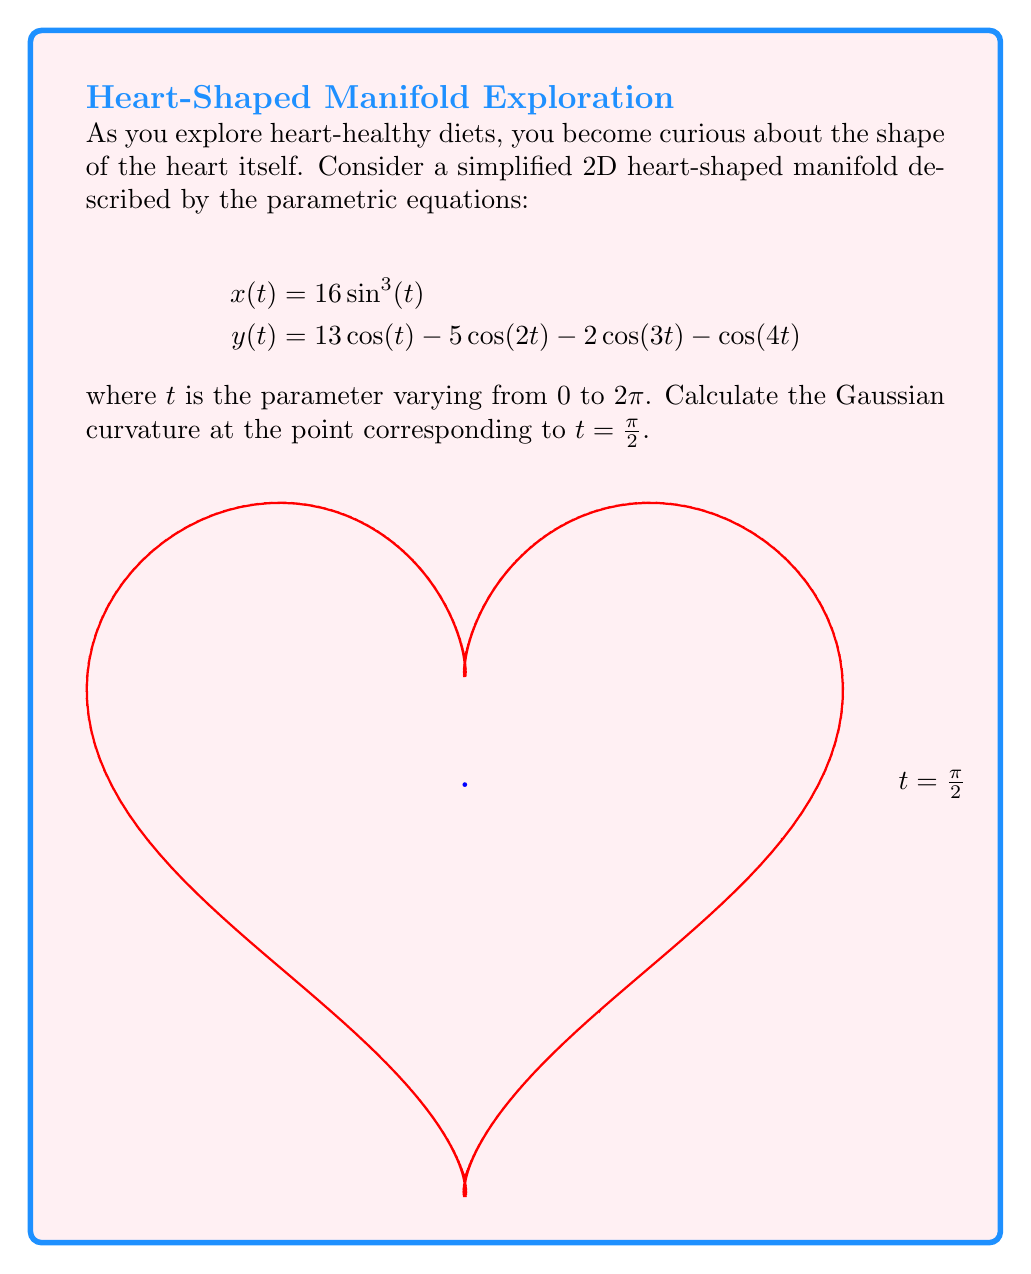Teach me how to tackle this problem. To calculate the Gaussian curvature, we need to follow these steps:

1) First, we need to calculate the first and second derivatives of x and y with respect to t:

   $$x'(t) = 48\sin^2(t)\cos(t)$$
   $$y'(t) = -13\sin(t) + 10\sin(2t) + 6\sin(3t) + 4\sin(4t)$$
   
   $$x''(t) = 96\sin(t)\cos^2(t) - 48\sin^3(t)$$
   $$y''(t) = -13\cos(t) + 20\cos(2t) + 18\cos(3t) + 16\cos(4t)$$

2) At $t = \frac{\pi}{2}$, we have:

   $$x'(\frac{\pi}{2}) = 48, y'(\frac{\pi}{2}) = 0$$
   $$x''(\frac{\pi}{2}) = 0, y''(\frac{\pi}{2}) = 13 + 20 - 18 + 16 = 31$$

3) The Gaussian curvature K is given by:

   $$K = \frac{x'y'' - x''y'}{(x'^2 + y'^2)^{\frac{3}{2}}}$$

4) Substituting our values:

   $$K = \frac{48 * 31 - 0 * 0}{(48^2 + 0^2)^{\frac{3}{2}}} = \frac{1488}{(2304)^{\frac{3}{2}}}$$

5) Simplifying:

   $$K = \frac{1488}{110592\sqrt{2304}} = \frac{1488}{110592 * 48} = \frac{31}{2304}$$
Answer: $K = \frac{31}{2304}$ 